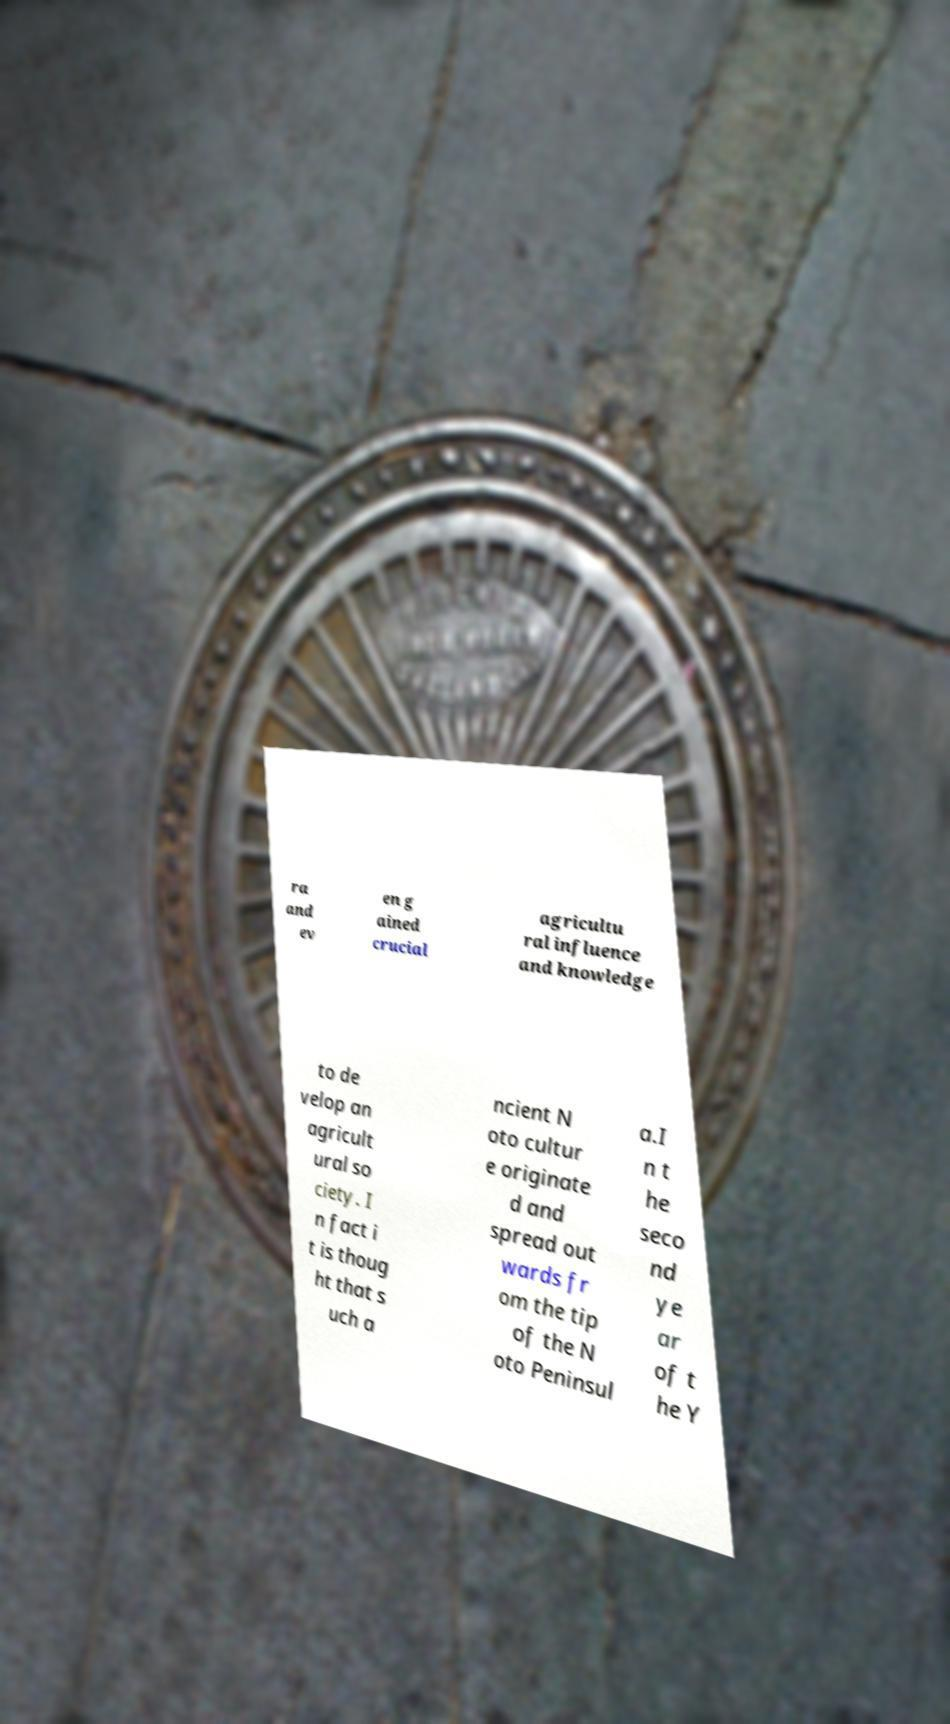Please identify and transcribe the text found in this image. ra and ev en g ained crucial agricultu ral influence and knowledge to de velop an agricult ural so ciety. I n fact i t is thoug ht that s uch a ncient N oto cultur e originate d and spread out wards fr om the tip of the N oto Peninsul a.I n t he seco nd ye ar of t he Y 